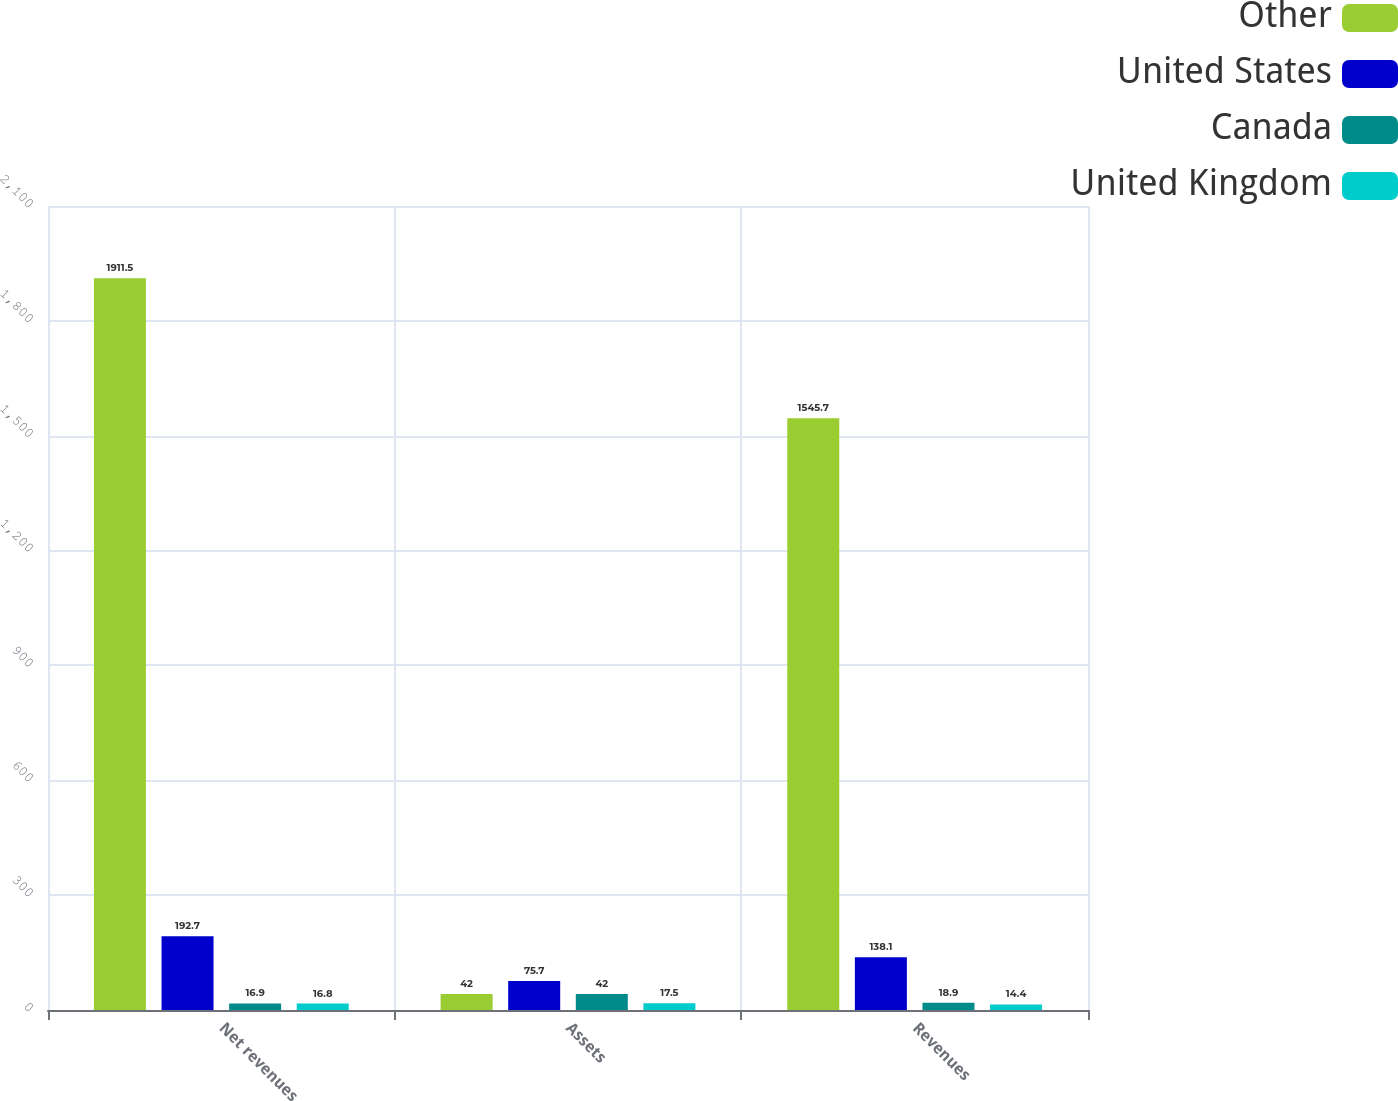<chart> <loc_0><loc_0><loc_500><loc_500><stacked_bar_chart><ecel><fcel>Net revenues<fcel>Assets<fcel>Revenues<nl><fcel>Other<fcel>1911.5<fcel>42<fcel>1545.7<nl><fcel>United States<fcel>192.7<fcel>75.7<fcel>138.1<nl><fcel>Canada<fcel>16.9<fcel>42<fcel>18.9<nl><fcel>United Kingdom<fcel>16.8<fcel>17.5<fcel>14.4<nl></chart> 